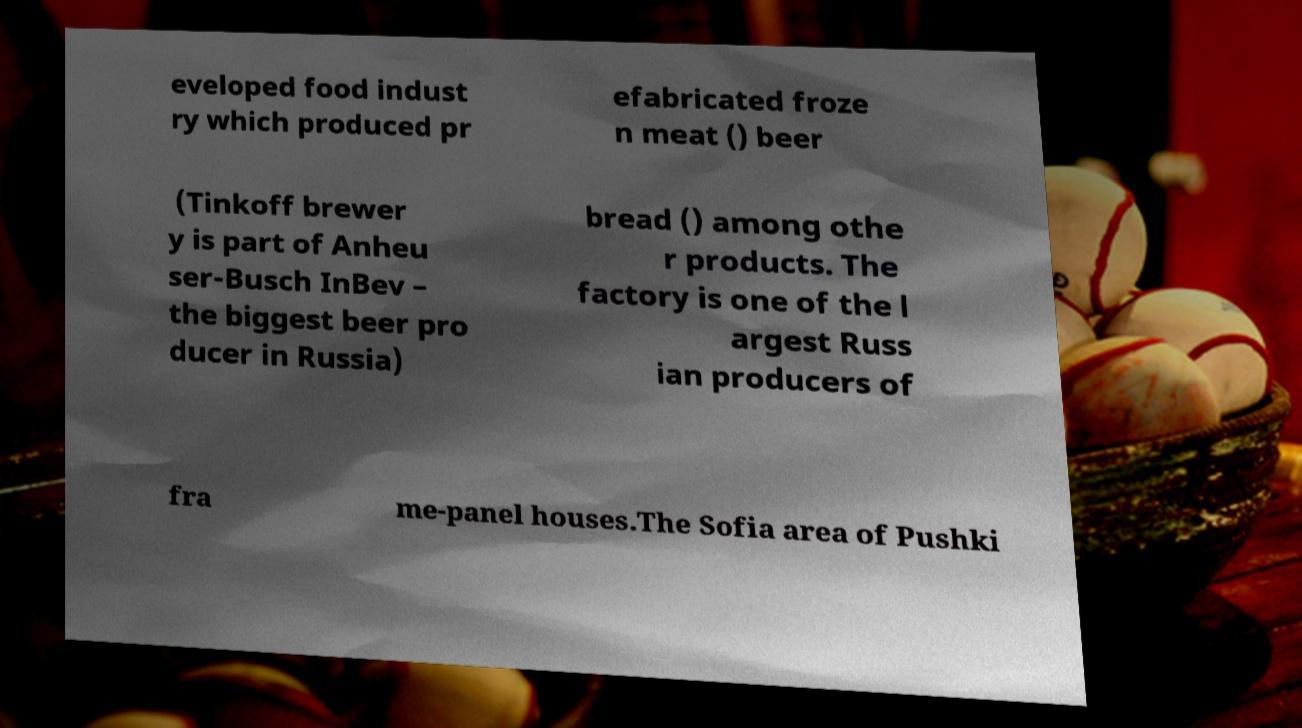There's text embedded in this image that I need extracted. Can you transcribe it verbatim? eveloped food indust ry which produced pr efabricated froze n meat () beer (Tinkoff brewer y is part of Anheu ser-Busch InBev – the biggest beer pro ducer in Russia) bread () among othe r products. The factory is one of the l argest Russ ian producers of fra me-panel houses.The Sofia area of Pushki 